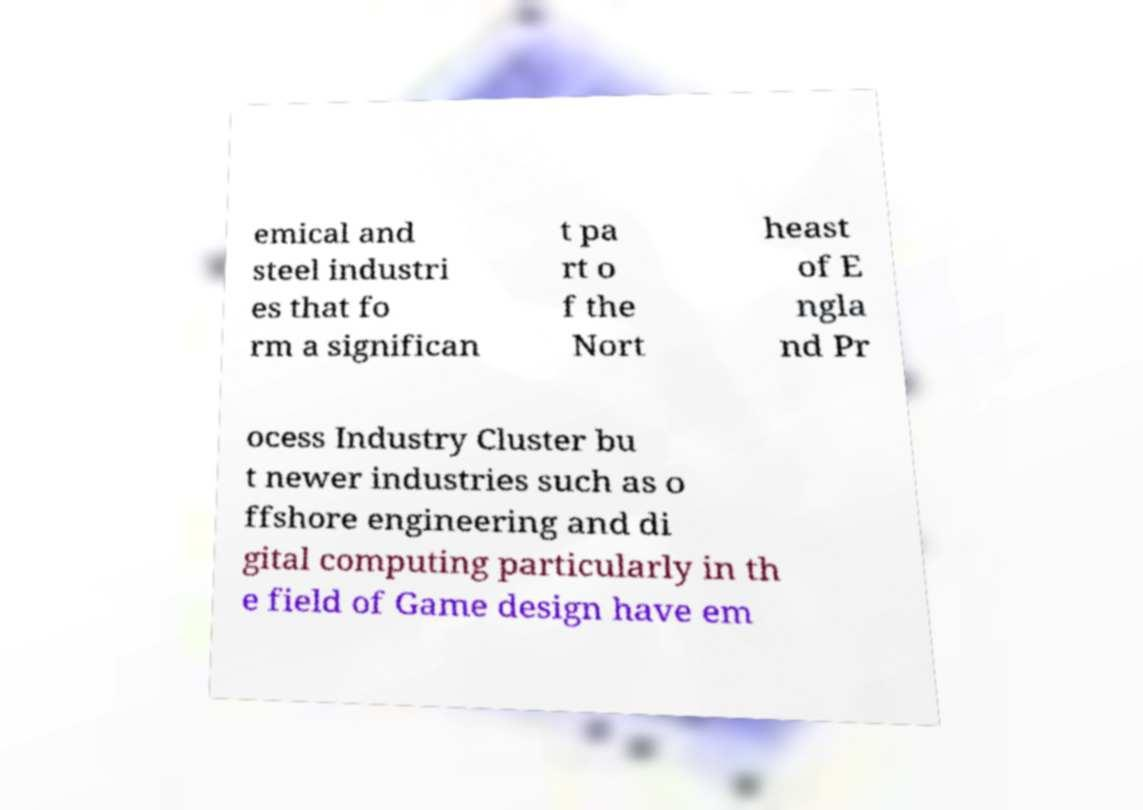For documentation purposes, I need the text within this image transcribed. Could you provide that? emical and steel industri es that fo rm a significan t pa rt o f the Nort heast of E ngla nd Pr ocess Industry Cluster bu t newer industries such as o ffshore engineering and di gital computing particularly in th e field of Game design have em 